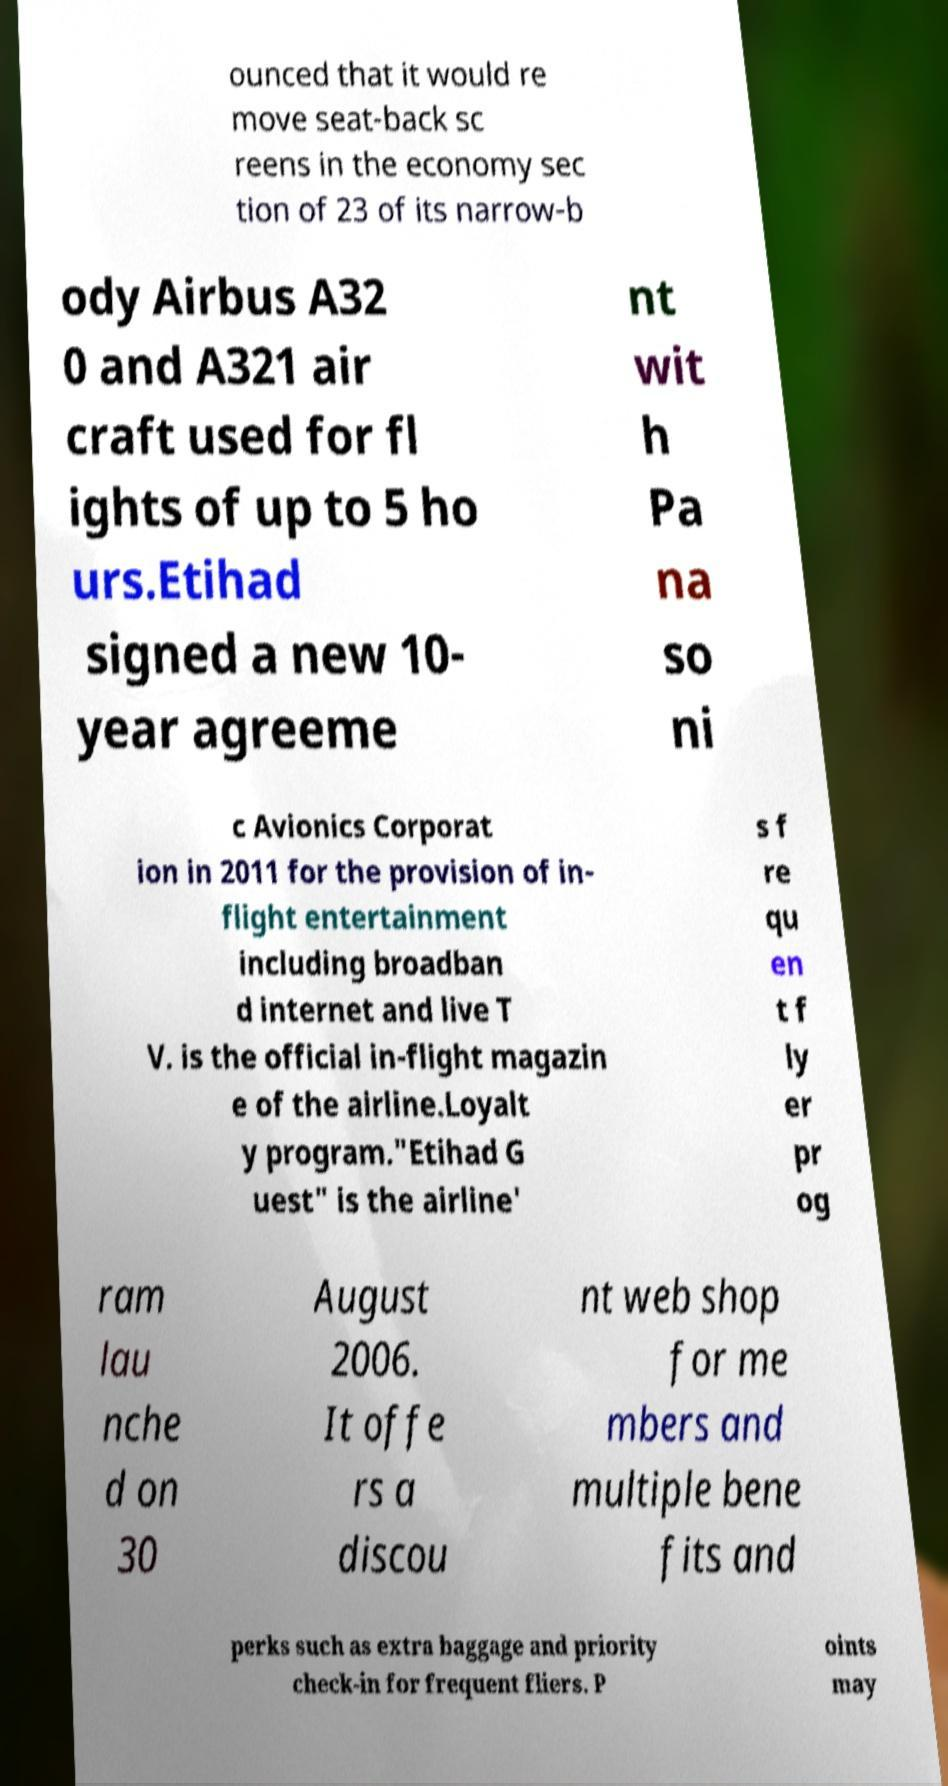There's text embedded in this image that I need extracted. Can you transcribe it verbatim? ounced that it would re move seat-back sc reens in the economy sec tion of 23 of its narrow-b ody Airbus A32 0 and A321 air craft used for fl ights of up to 5 ho urs.Etihad signed a new 10- year agreeme nt wit h Pa na so ni c Avionics Corporat ion in 2011 for the provision of in- flight entertainment including broadban d internet and live T V. is the official in-flight magazin e of the airline.Loyalt y program."Etihad G uest" is the airline' s f re qu en t f ly er pr og ram lau nche d on 30 August 2006. It offe rs a discou nt web shop for me mbers and multiple bene fits and perks such as extra baggage and priority check-in for frequent fliers. P oints may 